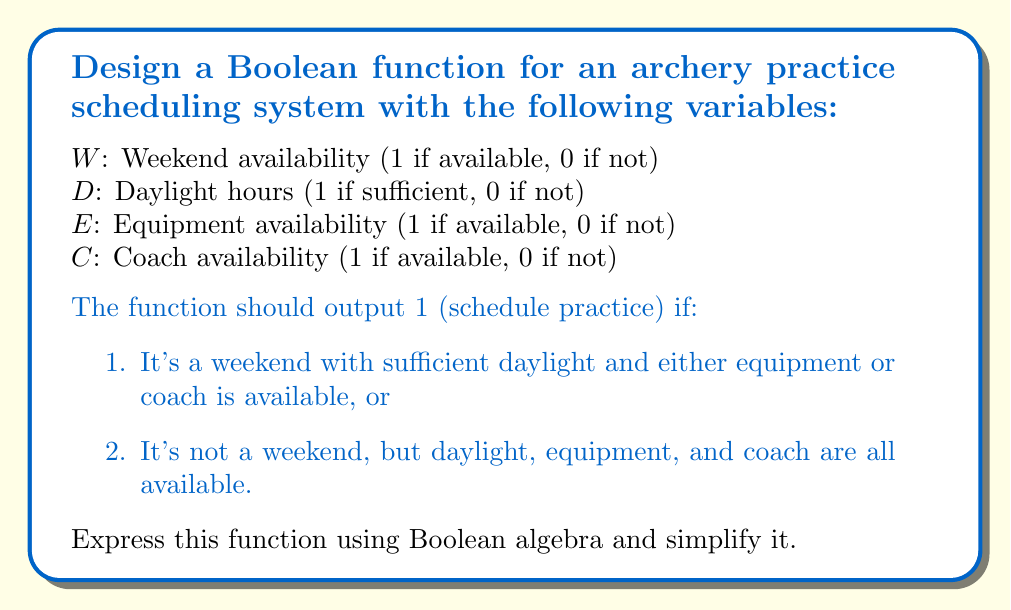Could you help me with this problem? Let's approach this step-by-step:

1) First, let's express the conditions in Boolean algebra:

   Condition 1: $W \cdot D \cdot (E + C)$
   Condition 2: $\overline{W} \cdot D \cdot E \cdot C$

2) The complete function is the OR of these conditions:

   $F = W \cdot D \cdot (E + C) + \overline{W} \cdot D \cdot E \cdot C$

3) Let's simplify this using Boolean algebra laws:

   $F = W \cdot D \cdot (E + C) + \overline{W} \cdot D \cdot E \cdot C$
   
   $= D \cdot [W \cdot (E + C) + \overline{W} \cdot E \cdot C]$  (Factoring out D)
   
   $= D \cdot [W \cdot E + W \cdot C + \overline{W} \cdot E \cdot C]$  (Distributive law)
   
   $= D \cdot [E \cdot (W + \overline{W} \cdot C) + W \cdot C]$  (Factoring out E)
   
   $= D \cdot [E \cdot (W + C) + W \cdot C]$  (Absorption law: $W + \overline{W} \cdot C = W + C$)

4) This is the simplified Boolean function for the scheduling system.
Answer: $F = D \cdot [E \cdot (W + C) + W \cdot C]$ 